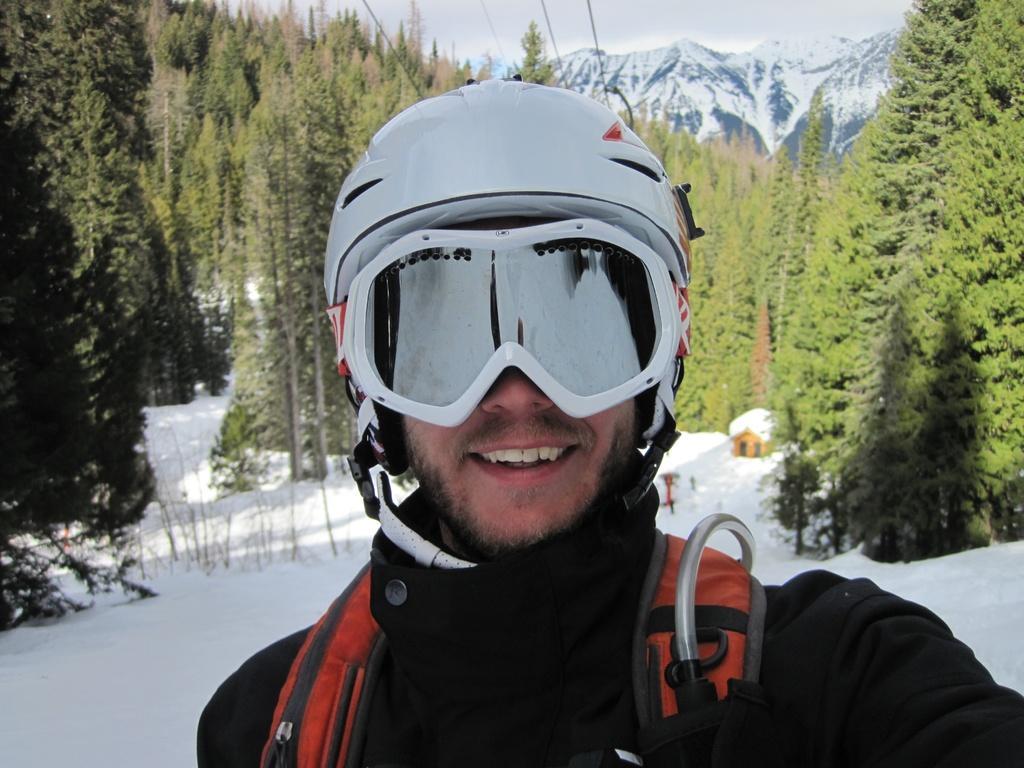Can you describe this image briefly? In the image there is a man with a helmet on his head. And he kept goggles. And he wore a bag. Behind him on the ground there is snow and also there are trees. Behind the trees there are mountains covered with snow. 